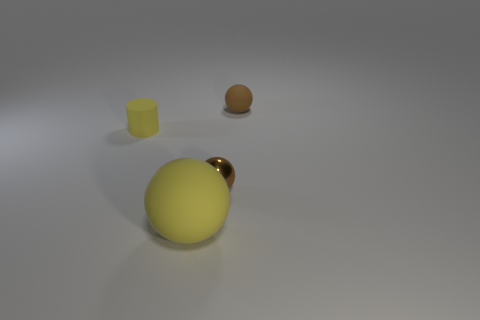Are there any other things that have the same size as the yellow ball?
Offer a terse response. No. What is the material of the small thing to the left of the big rubber sphere?
Offer a terse response. Rubber. Is the color of the shiny object the same as the tiny matte object right of the big matte ball?
Your response must be concise. Yes. What number of things are either small brown things right of the tiny shiny ball or rubber things on the right side of the large yellow matte object?
Offer a terse response. 1. There is a ball that is to the left of the tiny matte sphere and behind the yellow sphere; what color is it?
Provide a short and direct response. Brown. Is the number of tiny brown metal spheres greater than the number of things?
Make the answer very short. No. Is the shape of the tiny brown thing that is to the left of the brown matte object the same as  the big rubber thing?
Your response must be concise. Yes. What number of metallic things are either cylinders or large objects?
Make the answer very short. 0. Are there any big brown spheres made of the same material as the large thing?
Give a very brief answer. No. What is the small yellow cylinder made of?
Give a very brief answer. Rubber. 